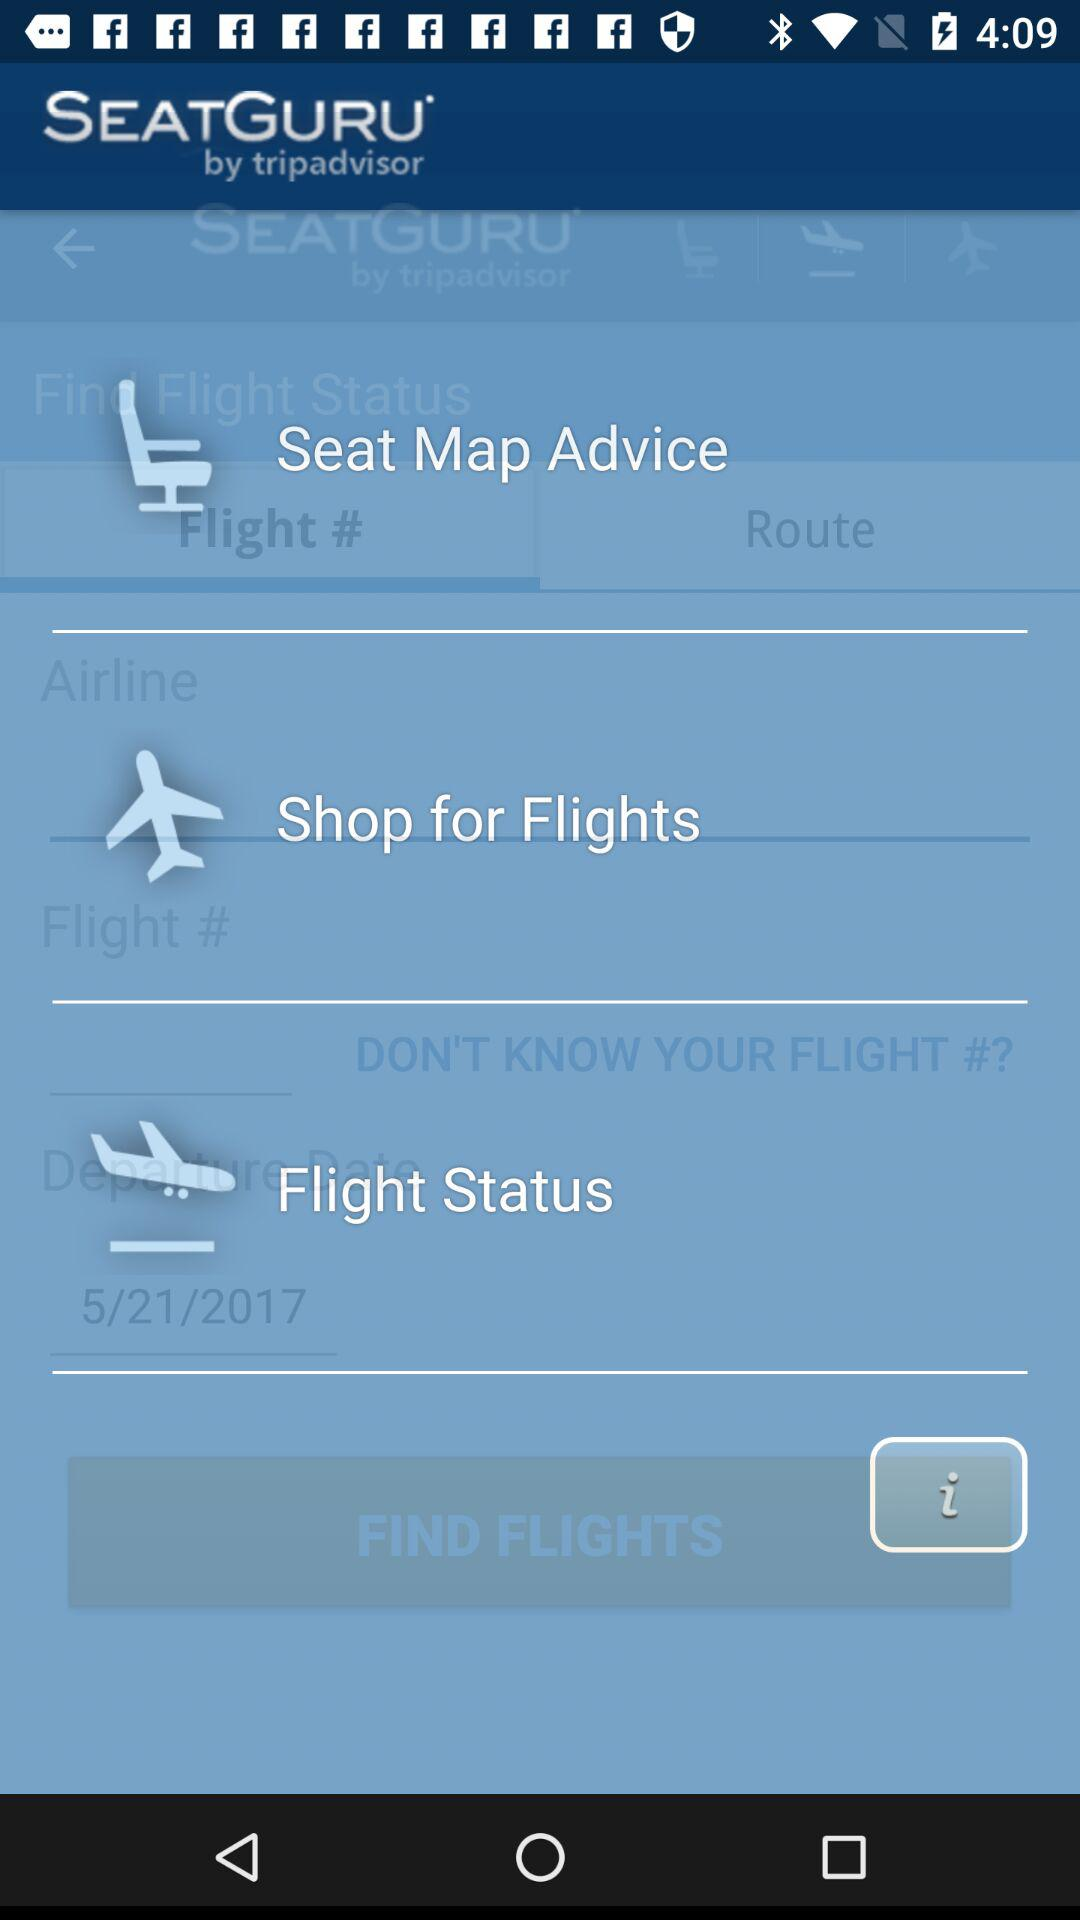What is the name of the application? The name of the application is "SEATGURU by tripadvisor". 